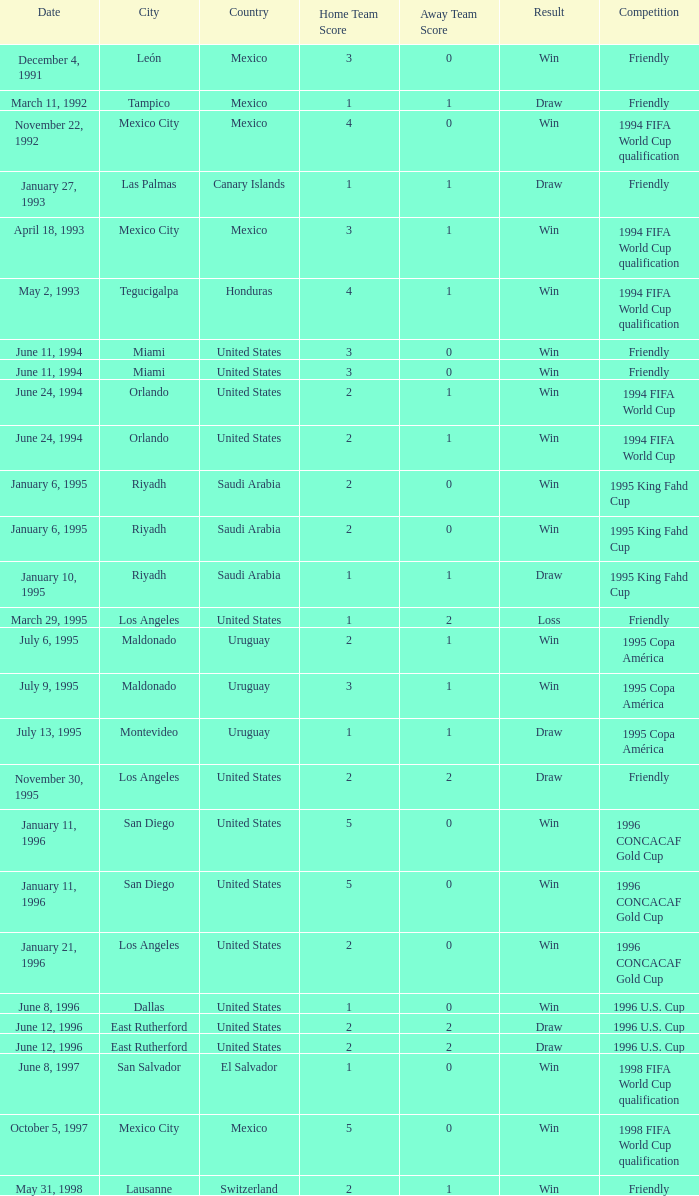What is Result, when Date is "June 11, 1994", and when Venue is "Miami, United States"? Win, Win. 